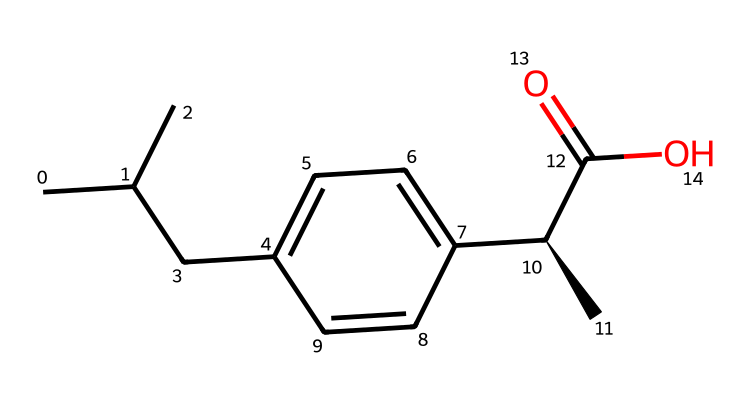What is the molecular formula of ibuprofen? To find the molecular formula, we count the number of each type of atom in the SMILES representation. The chemical has 13 carbons (C), 18 hydrogens (H), and 2 oxygens (O). Therefore, the molecular formula is C13H18O2.
Answer: C13H18O2 How many rings are present in the structure? By analyzing the SMILES, we observe that there are no cyclic structures present; only linear and branched carbon chains. Hence, the number of rings is zero.
Answer: zero What functional group is present in ibuprofen? Observing the structure, we can identify the carboxylic acid functional group, which is indicated by the -C(=O)O portion of the SMILES. This functional group is known for its acidic properties.
Answer: carboxylic acid How many stereocenters does ibuprofen have? Looking closely at the structure, we notice there is one chiral carbon indicated by the C@ symbol in the SMILES line. This indicates the presence of one stereocenter in the molecule.
Answer: one What type of bonding is primarily present in ibuprofen? The majority of the bonding type in this organic compound is covalent, as evidenced by the multiple carbon-carbon and carbon-hydrogen bonds revealed in the SMILES structure.
Answer: covalent Which part of the structure is responsible for its pain-relieving properties? The carboxylic acid group is involved in the interaction with cyclooxygenase enzymes which play a crucial role in inflammation and pain. This part of the structure is key to ibuprofen's analgesic properties.
Answer: carboxylic acid group 